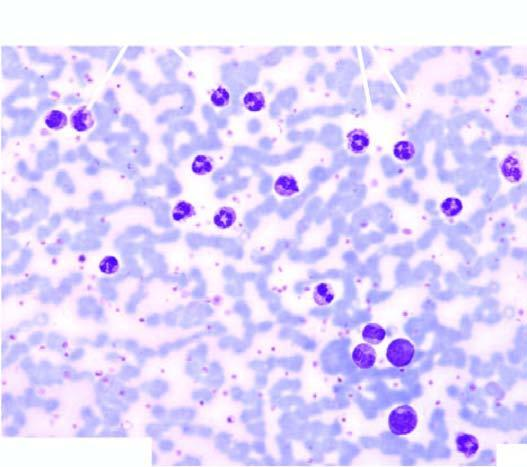s ctive granulation tissue accompanied with late precursors of myeloid series?
Answer the question using a single word or phrase. No 